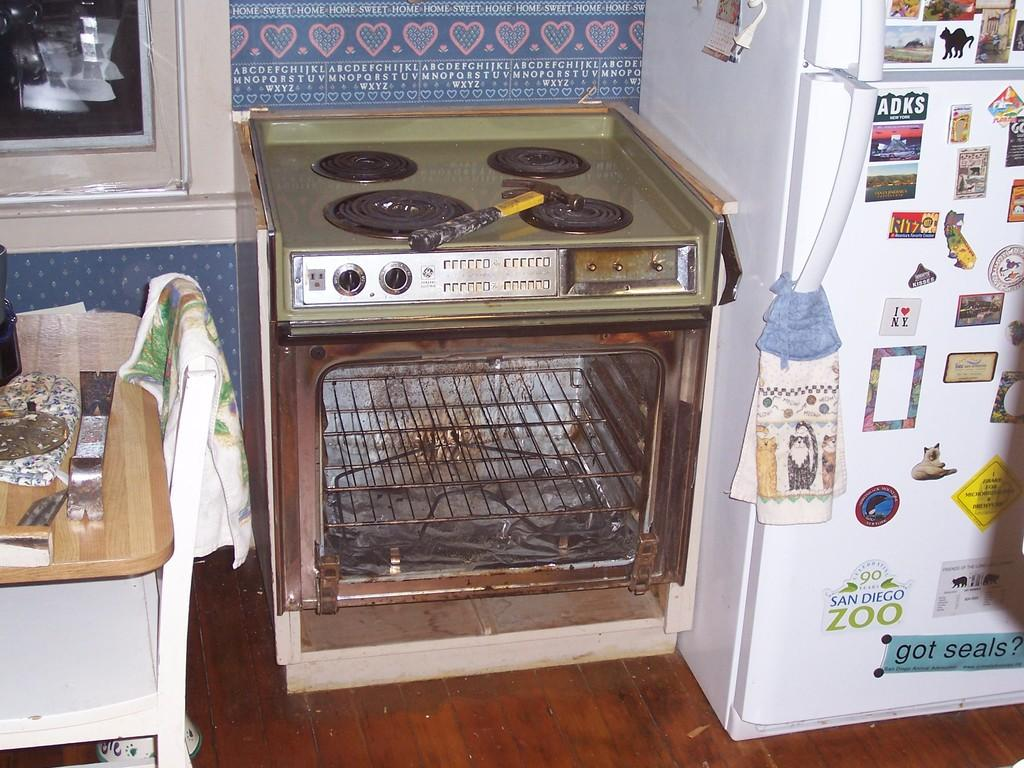<image>
Describe the image concisely. A white fridge has a sticker from the San Diego Zoo on it. 